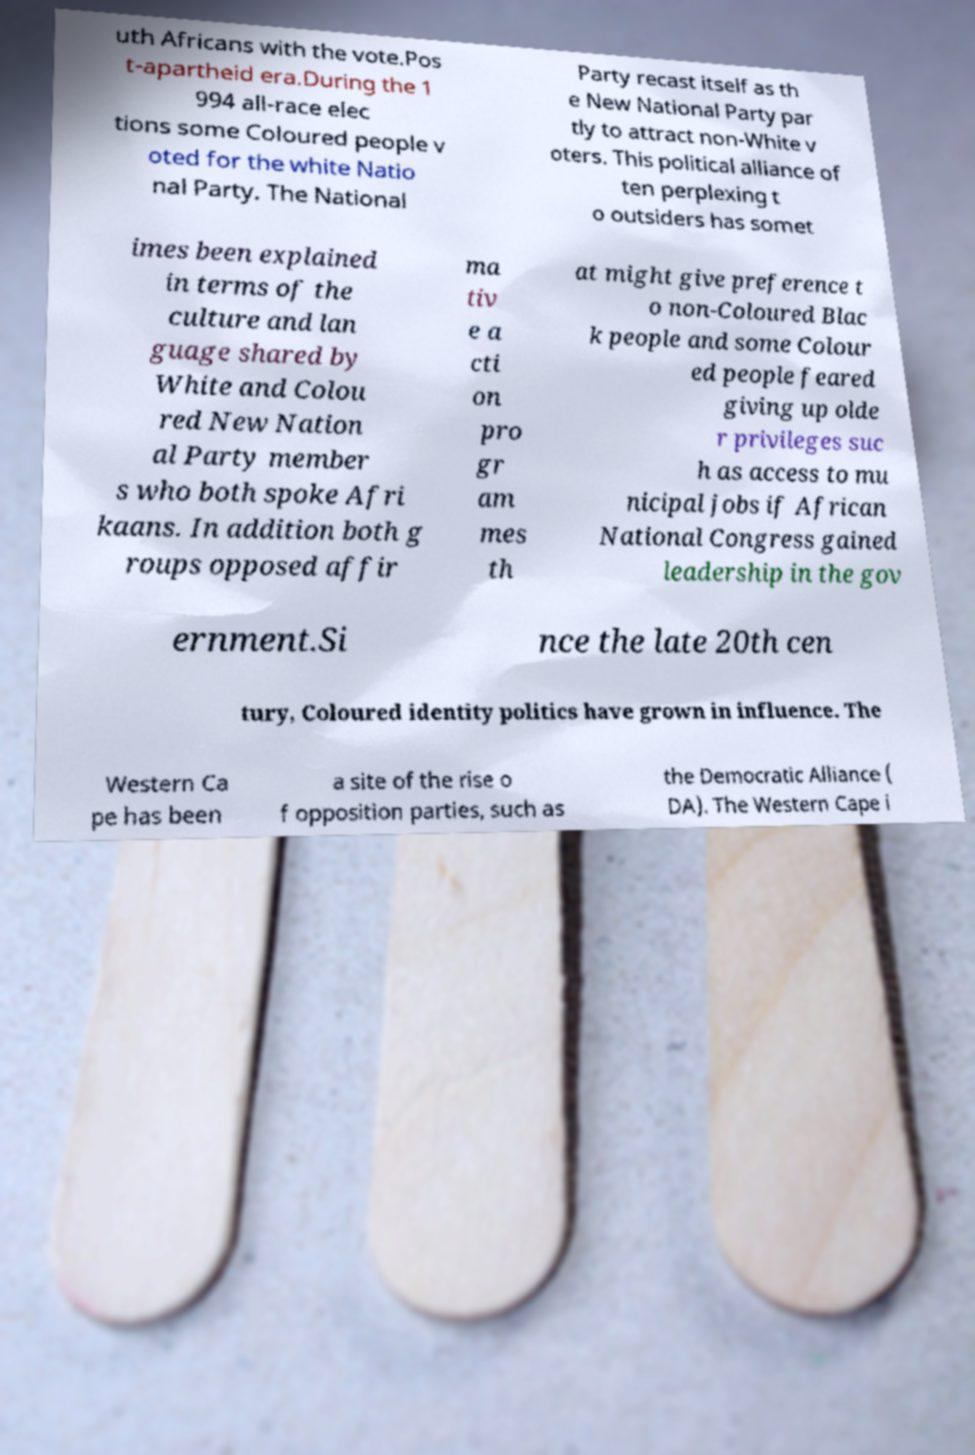I need the written content from this picture converted into text. Can you do that? uth Africans with the vote.Pos t-apartheid era.During the 1 994 all-race elec tions some Coloured people v oted for the white Natio nal Party. The National Party recast itself as th e New National Party par tly to attract non-White v oters. This political alliance of ten perplexing t o outsiders has somet imes been explained in terms of the culture and lan guage shared by White and Colou red New Nation al Party member s who both spoke Afri kaans. In addition both g roups opposed affir ma tiv e a cti on pro gr am mes th at might give preference t o non-Coloured Blac k people and some Colour ed people feared giving up olde r privileges suc h as access to mu nicipal jobs if African National Congress gained leadership in the gov ernment.Si nce the late 20th cen tury, Coloured identity politics have grown in influence. The Western Ca pe has been a site of the rise o f opposition parties, such as the Democratic Alliance ( DA). The Western Cape i 